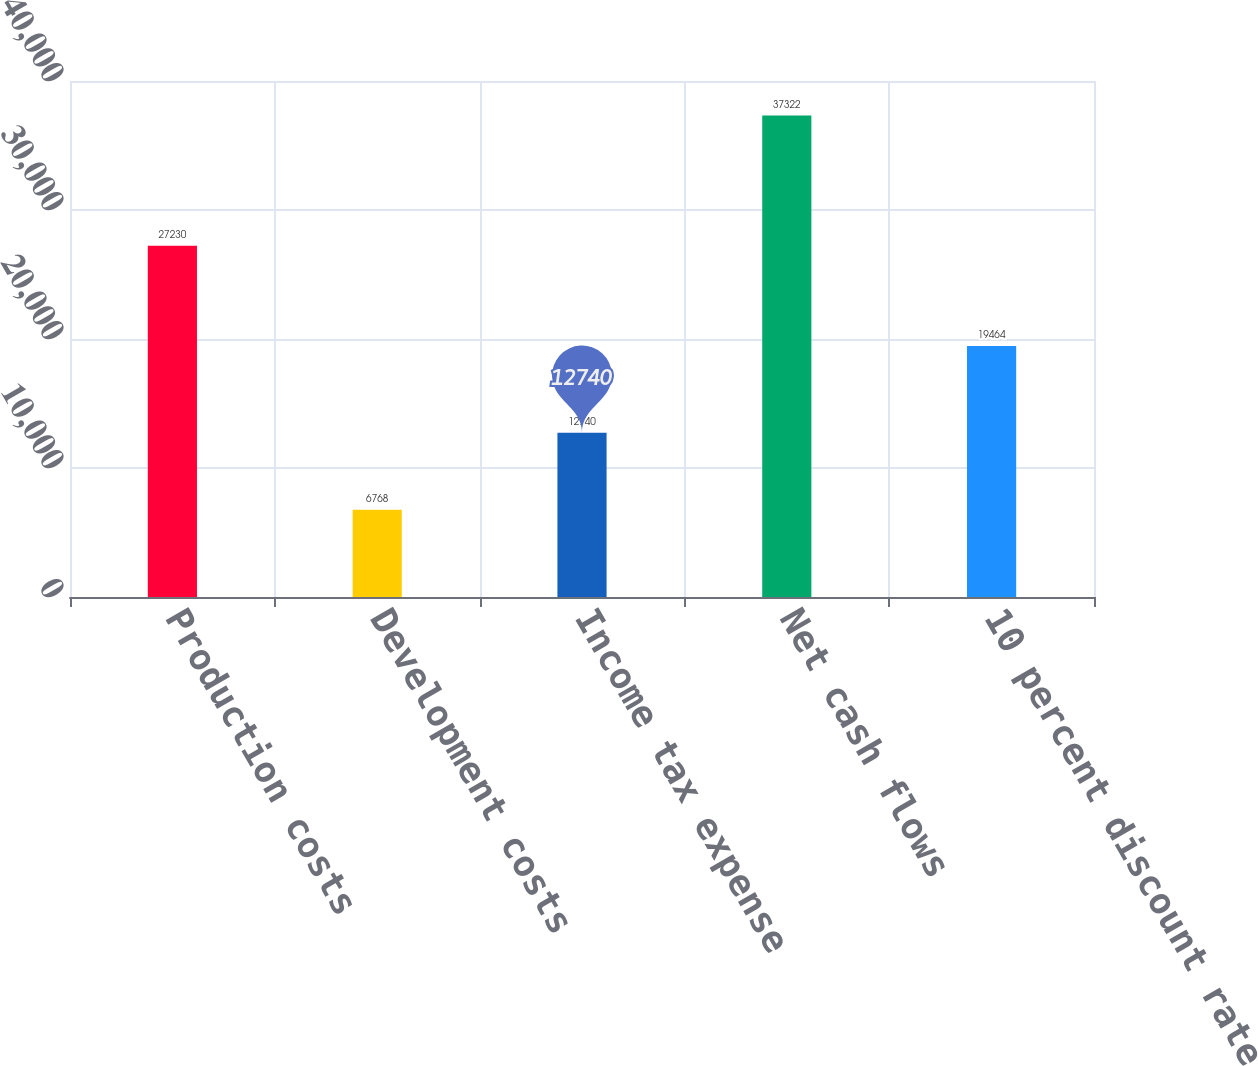Convert chart. <chart><loc_0><loc_0><loc_500><loc_500><bar_chart><fcel>Production costs<fcel>Development costs<fcel>Income tax expense<fcel>Net cash flows<fcel>10 percent discount rate<nl><fcel>27230<fcel>6768<fcel>12740<fcel>37322<fcel>19464<nl></chart> 